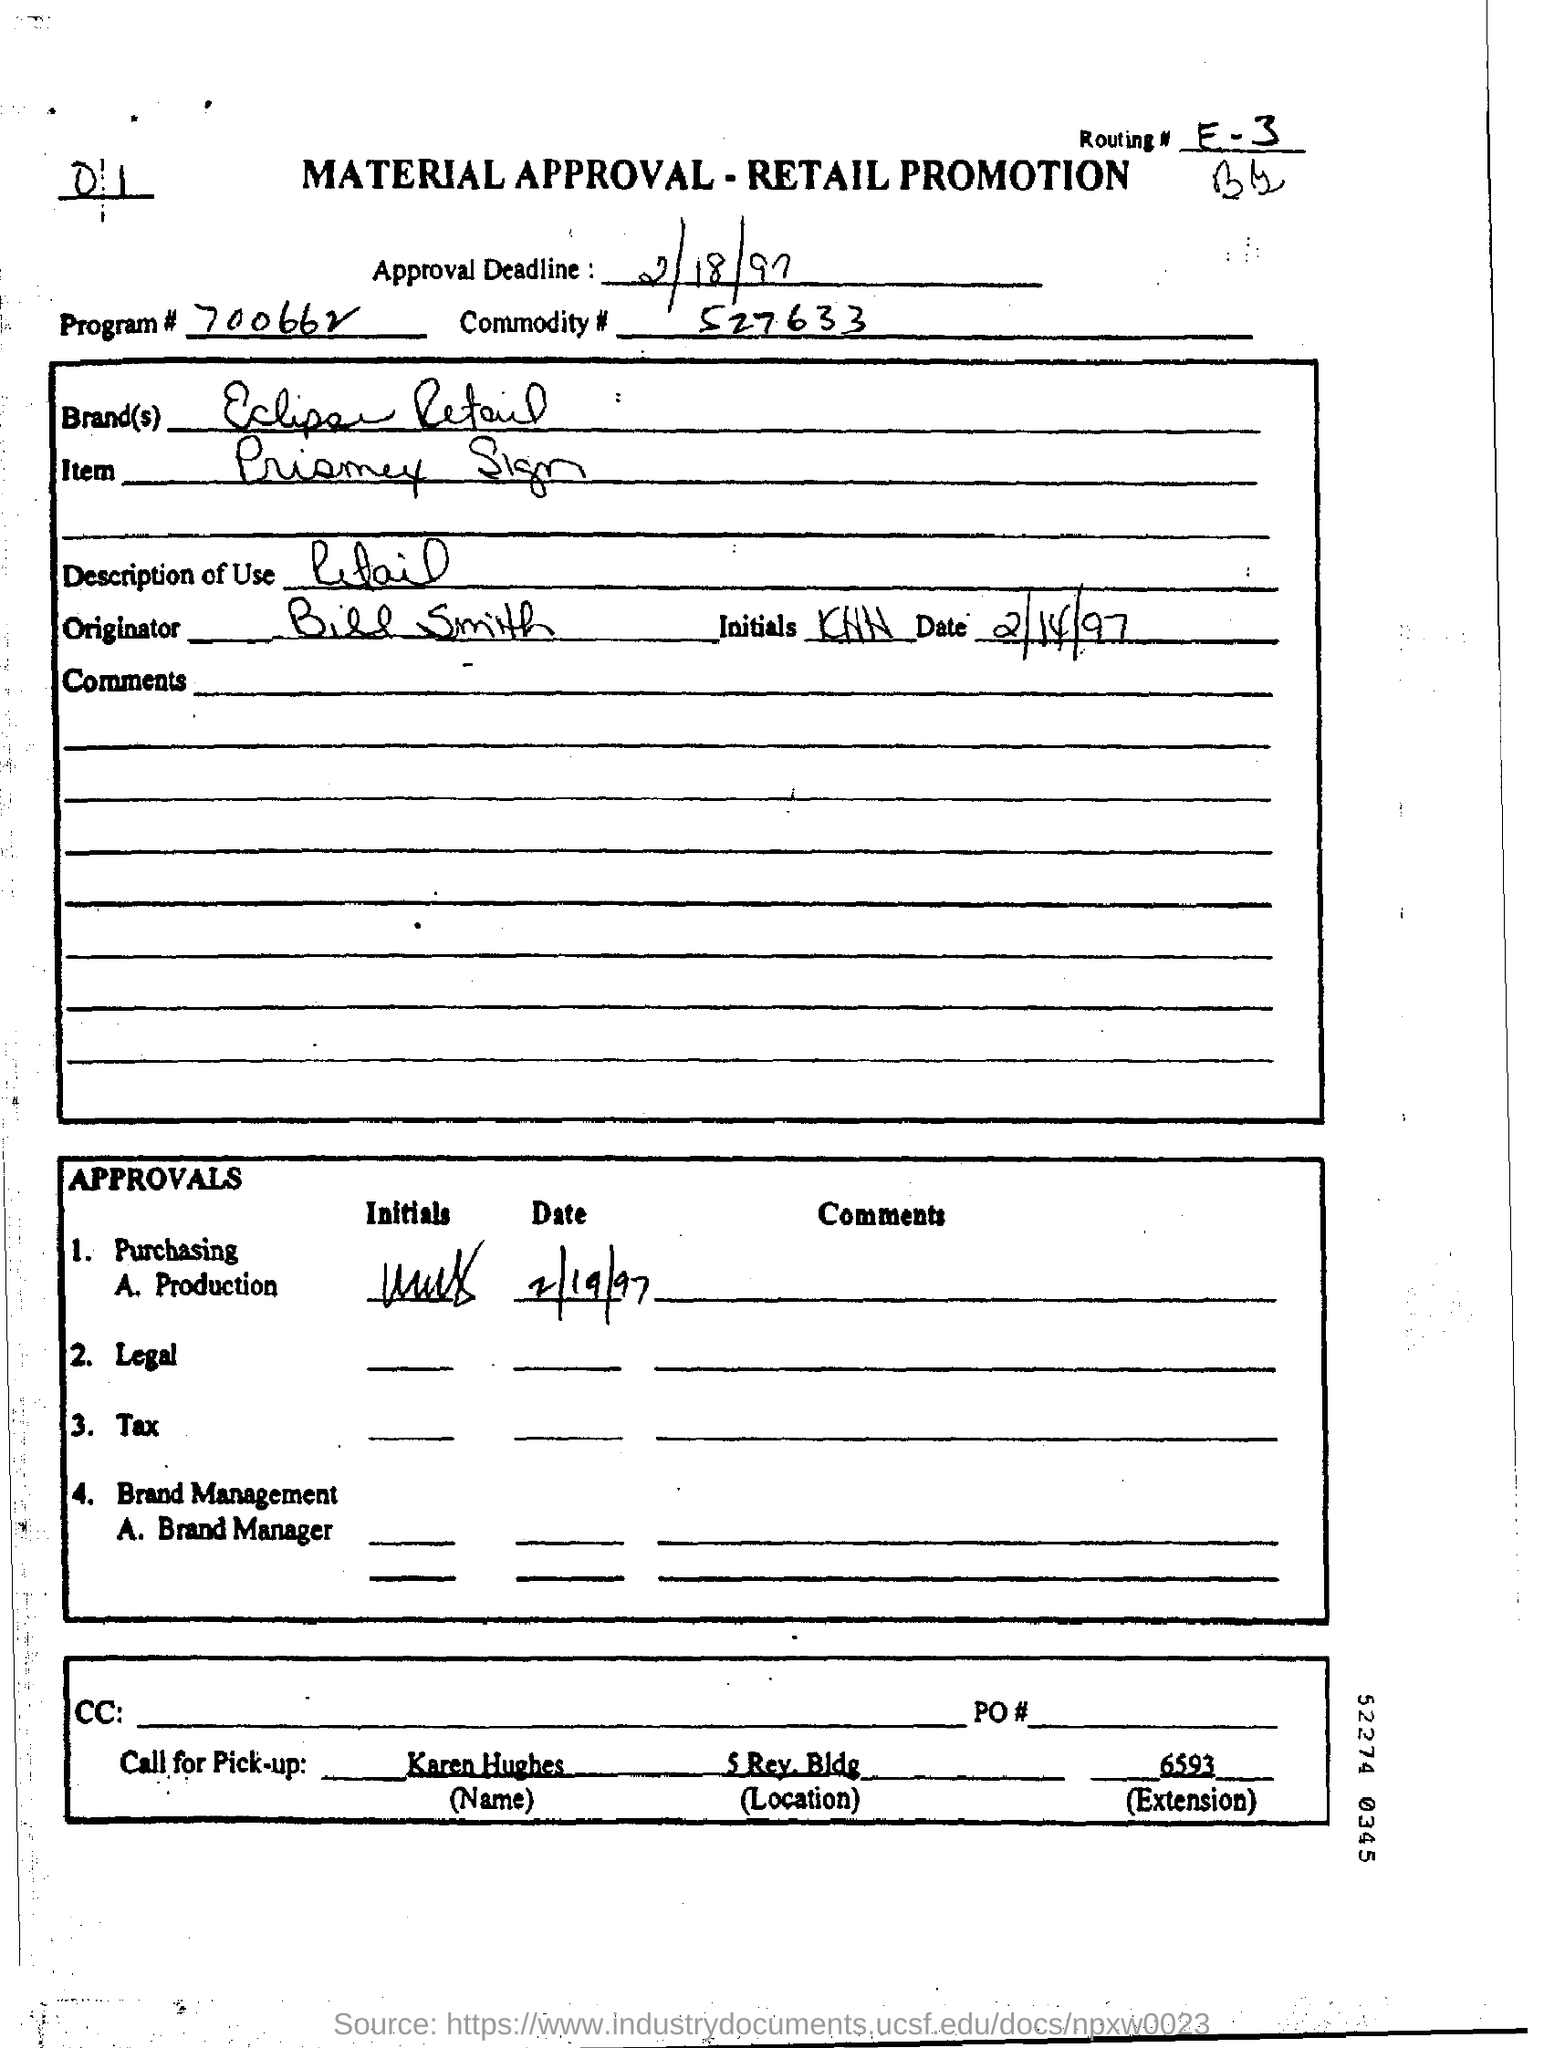What is the Brand Name ?
Make the answer very short. Eclipse Retail. What is the Description of use ?
Give a very brief answer. Retail. Who is the Originator ?
Your answer should be compact. Bill Smith. What is the Program Number ?
Your answer should be compact. 700662. Who will answer the call for pick-up ?
Keep it short and to the point. Karen Hughes. 